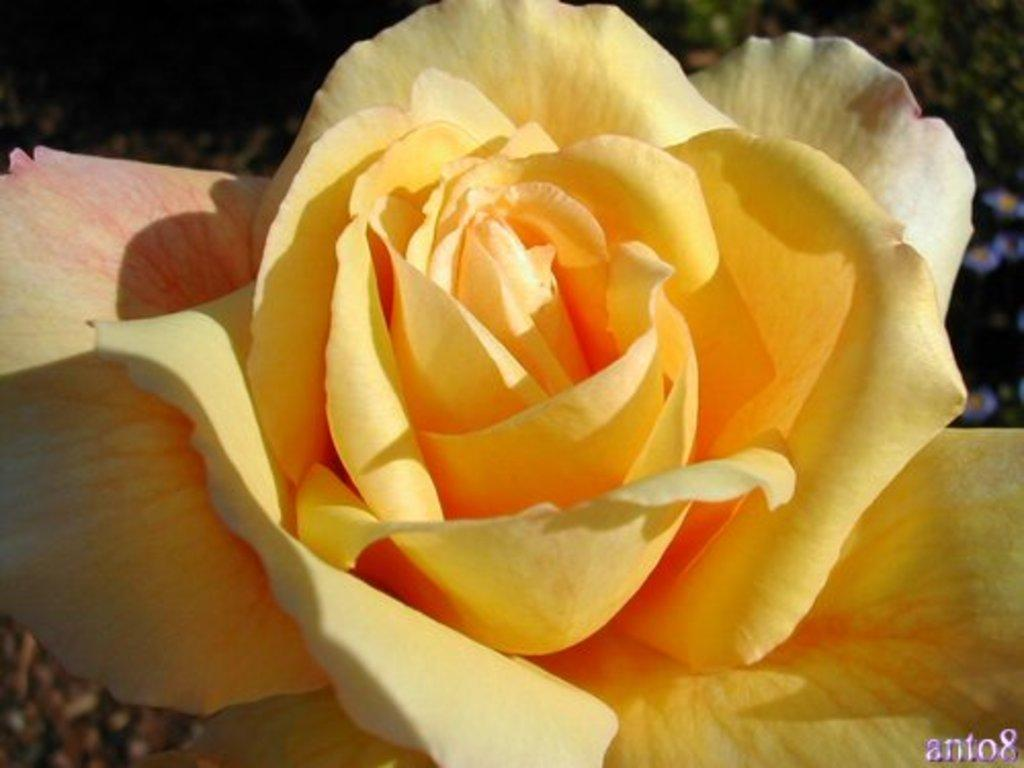What is the main subject of the image? There is a flower in the image. Can you describe the color of the flower? The flower is yellow in color. How many boats are visible in the image? There are no boats present in the image; it features a yellow flower. Is the horse standing on a crate in the image? There is no horse or crate present in the image. 